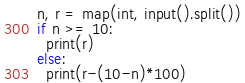<code> <loc_0><loc_0><loc_500><loc_500><_Python_>n, r = map(int, input().split())
if n >= 10:
  print(r)
else:
  print(r-(10-n)*100)</code> 